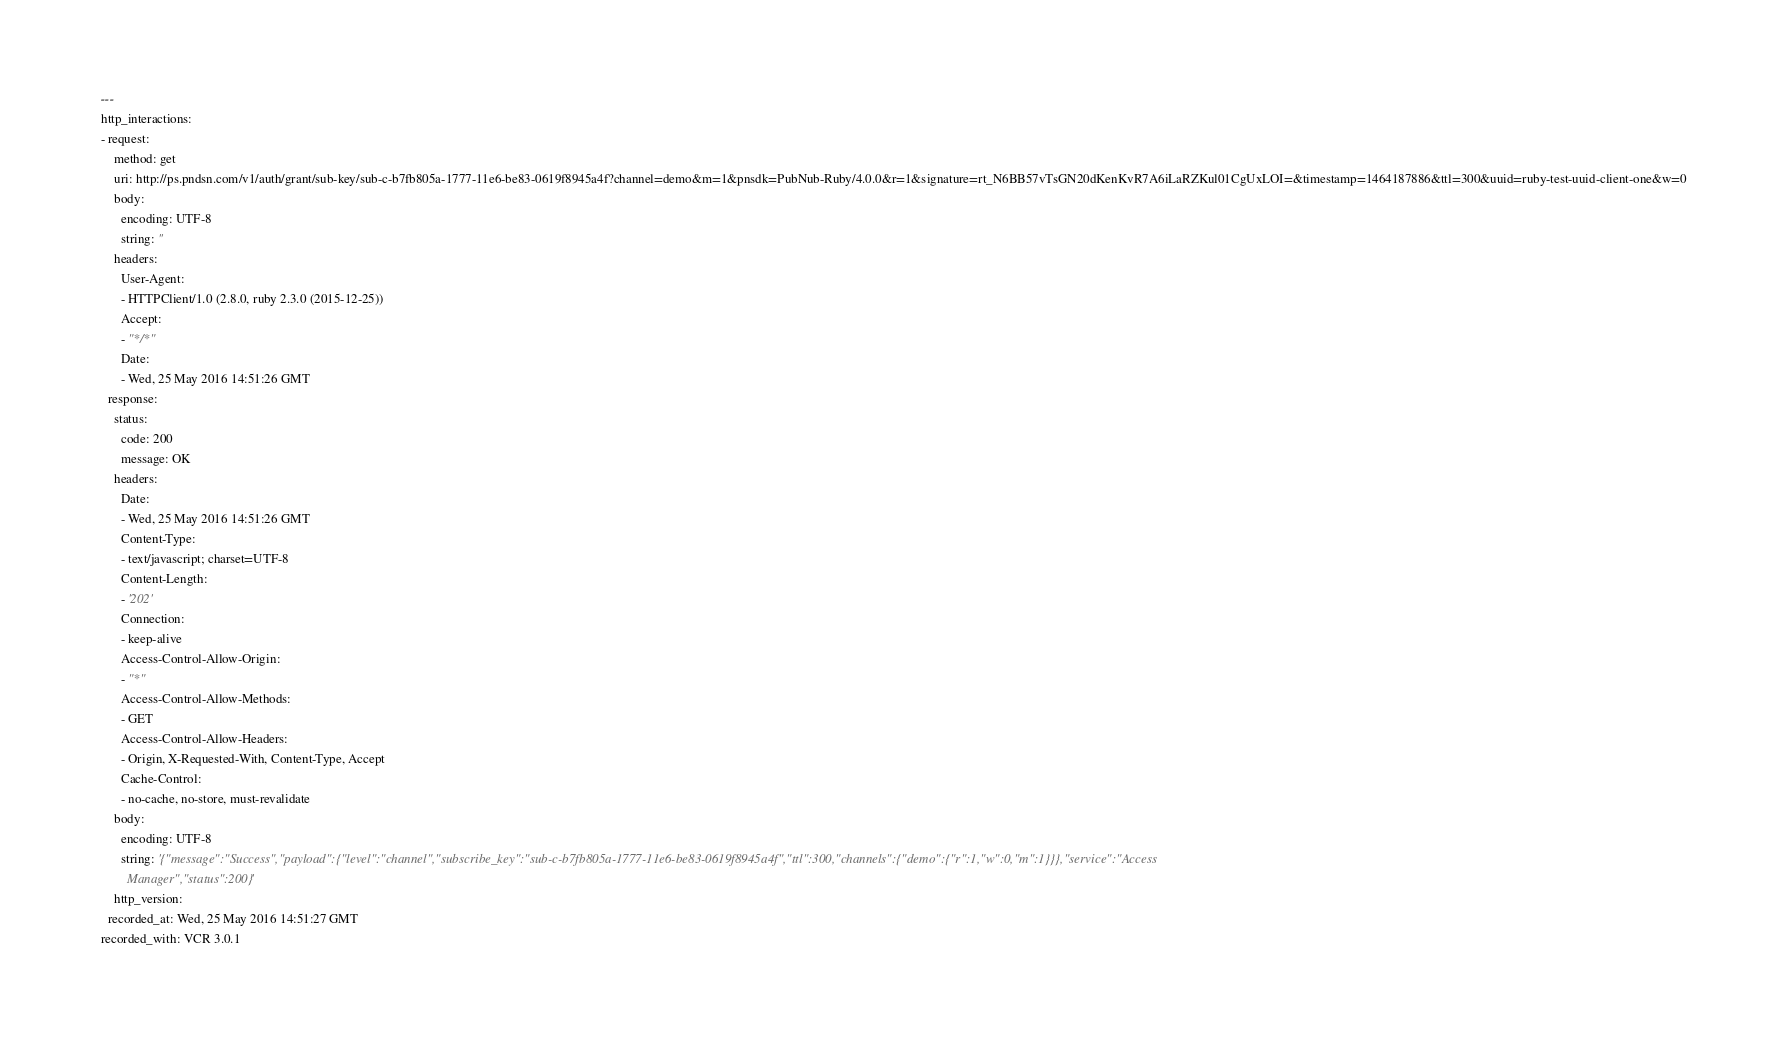Convert code to text. <code><loc_0><loc_0><loc_500><loc_500><_YAML_>---
http_interactions:
- request:
    method: get
    uri: http://ps.pndsn.com/v1/auth/grant/sub-key/sub-c-b7fb805a-1777-11e6-be83-0619f8945a4f?channel=demo&m=1&pnsdk=PubNub-Ruby/4.0.0&r=1&signature=rt_N6BB57vTsGN20dKenKvR7A6iLaRZKul01CgUxLOI=&timestamp=1464187886&ttl=300&uuid=ruby-test-uuid-client-one&w=0
    body:
      encoding: UTF-8
      string: ''
    headers:
      User-Agent:
      - HTTPClient/1.0 (2.8.0, ruby 2.3.0 (2015-12-25))
      Accept:
      - "*/*"
      Date:
      - Wed, 25 May 2016 14:51:26 GMT
  response:
    status:
      code: 200
      message: OK
    headers:
      Date:
      - Wed, 25 May 2016 14:51:26 GMT
      Content-Type:
      - text/javascript; charset=UTF-8
      Content-Length:
      - '202'
      Connection:
      - keep-alive
      Access-Control-Allow-Origin:
      - "*"
      Access-Control-Allow-Methods:
      - GET
      Access-Control-Allow-Headers:
      - Origin, X-Requested-With, Content-Type, Accept
      Cache-Control:
      - no-cache, no-store, must-revalidate
    body:
      encoding: UTF-8
      string: '{"message":"Success","payload":{"level":"channel","subscribe_key":"sub-c-b7fb805a-1777-11e6-be83-0619f8945a4f","ttl":300,"channels":{"demo":{"r":1,"w":0,"m":1}}},"service":"Access
        Manager","status":200}'
    http_version: 
  recorded_at: Wed, 25 May 2016 14:51:27 GMT
recorded_with: VCR 3.0.1
</code> 